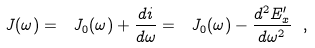<formula> <loc_0><loc_0><loc_500><loc_500>\ J ( \omega ) = \ J _ { 0 } ( \omega ) + \frac { d i } { d \omega } = \ J _ { 0 } ( \omega ) - \frac { d ^ { 2 } E ^ { \prime } _ { x } } { d \omega ^ { 2 } } \ ,</formula> 